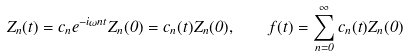<formula> <loc_0><loc_0><loc_500><loc_500>Z _ { n } ( t ) = c _ { n } e ^ { - i \omega n t } Z _ { n } ( 0 ) = c _ { n } ( t ) Z _ { n } ( 0 ) , \quad f ( t ) = \sum _ { n = 0 } ^ { \infty } c _ { n } ( t ) Z _ { n } ( 0 )</formula> 